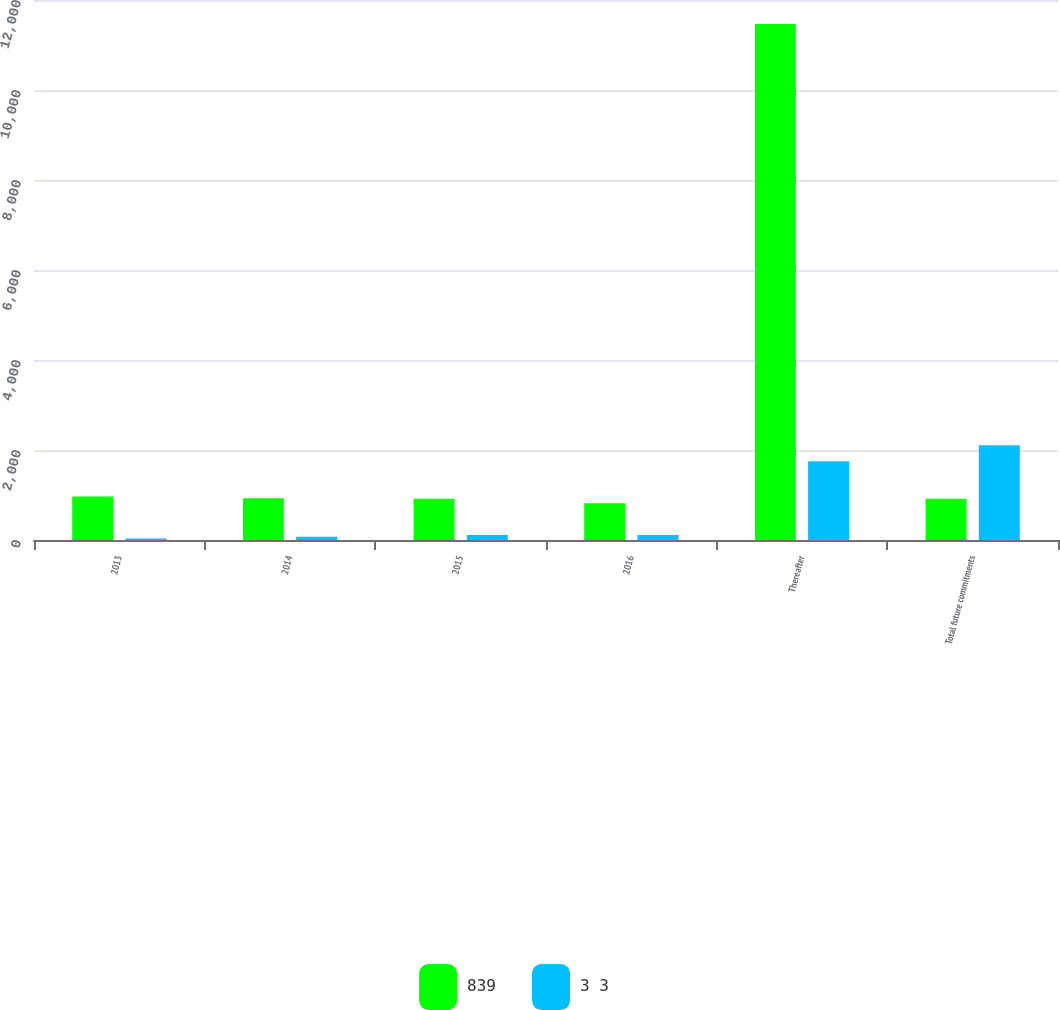Convert chart. <chart><loc_0><loc_0><loc_500><loc_500><stacked_bar_chart><ecel><fcel>2013<fcel>2014<fcel>2015<fcel>2016<fcel>Thereafter<fcel>Total future commitments<nl><fcel>839<fcel>966<fcel>930<fcel>916<fcel>815<fcel>11468<fcel>916<nl><fcel>3 3<fcel>33<fcel>72<fcel>109<fcel>109<fcel>1751<fcel>2107<nl></chart> 